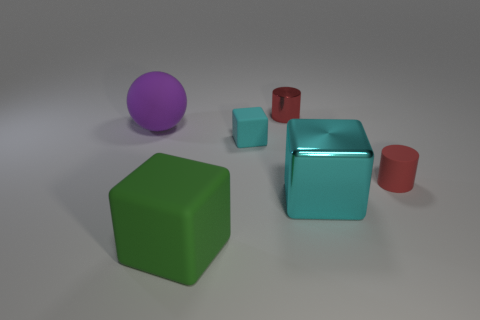Add 1 large yellow cylinders. How many objects exist? 7 Subtract all spheres. How many objects are left? 5 Add 2 tiny rubber blocks. How many tiny rubber blocks are left? 3 Add 3 shiny things. How many shiny things exist? 5 Subtract 0 blue spheres. How many objects are left? 6 Subtract all big green matte things. Subtract all tiny cyan rubber things. How many objects are left? 4 